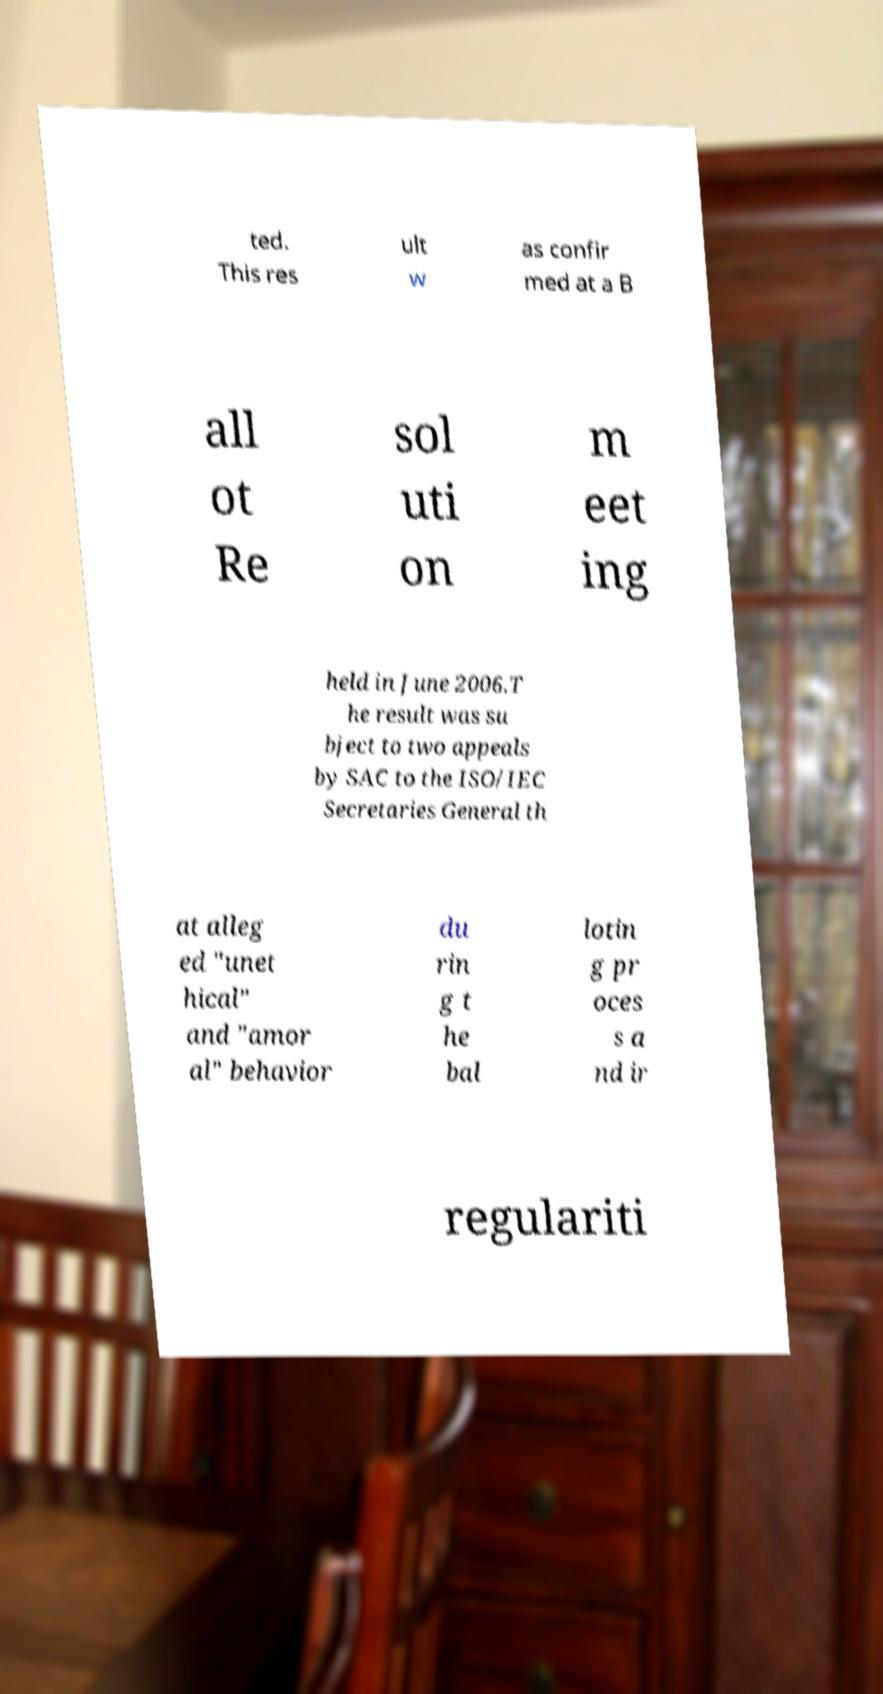Could you extract and type out the text from this image? ted. This res ult w as confir med at a B all ot Re sol uti on m eet ing held in June 2006.T he result was su bject to two appeals by SAC to the ISO/IEC Secretaries General th at alleg ed "unet hical" and "amor al" behavior du rin g t he bal lotin g pr oces s a nd ir regulariti 